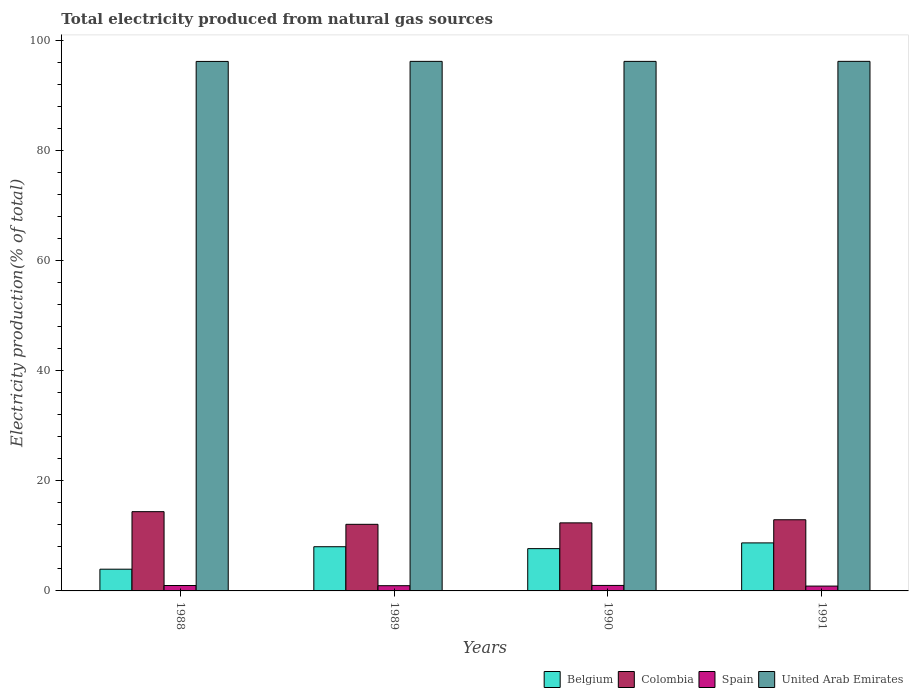How many different coloured bars are there?
Offer a terse response. 4. Are the number of bars per tick equal to the number of legend labels?
Your answer should be compact. Yes. In how many cases, is the number of bars for a given year not equal to the number of legend labels?
Ensure brevity in your answer.  0. What is the total electricity produced in Colombia in 1989?
Your answer should be compact. 12.11. Across all years, what is the maximum total electricity produced in Spain?
Ensure brevity in your answer.  1. Across all years, what is the minimum total electricity produced in Belgium?
Keep it short and to the point. 3.95. In which year was the total electricity produced in Belgium minimum?
Your response must be concise. 1988. What is the total total electricity produced in Spain in the graph?
Offer a terse response. 3.81. What is the difference between the total electricity produced in Belgium in 1989 and that in 1991?
Offer a very short reply. -0.7. What is the difference between the total electricity produced in United Arab Emirates in 1989 and the total electricity produced in Spain in 1991?
Offer a terse response. 95.41. What is the average total electricity produced in Belgium per year?
Offer a terse response. 7.1. In the year 1991, what is the difference between the total electricity produced in Spain and total electricity produced in United Arab Emirates?
Your response must be concise. -95.41. In how many years, is the total electricity produced in Spain greater than 16 %?
Offer a terse response. 0. What is the ratio of the total electricity produced in Colombia in 1990 to that in 1991?
Offer a very short reply. 0.96. Is the total electricity produced in United Arab Emirates in 1988 less than that in 1989?
Your answer should be compact. Yes. What is the difference between the highest and the second highest total electricity produced in Colombia?
Make the answer very short. 1.47. What is the difference between the highest and the lowest total electricity produced in Colombia?
Give a very brief answer. 2.3. Is the sum of the total electricity produced in Spain in 1988 and 1991 greater than the maximum total electricity produced in Colombia across all years?
Provide a short and direct response. No. Is it the case that in every year, the sum of the total electricity produced in Colombia and total electricity produced in United Arab Emirates is greater than the sum of total electricity produced in Belgium and total electricity produced in Spain?
Offer a very short reply. No. What does the 2nd bar from the left in 1988 represents?
Make the answer very short. Colombia. What does the 2nd bar from the right in 1988 represents?
Your response must be concise. Spain. Are all the bars in the graph horizontal?
Offer a terse response. No. How many years are there in the graph?
Offer a terse response. 4. What is the difference between two consecutive major ticks on the Y-axis?
Provide a short and direct response. 20. How many legend labels are there?
Give a very brief answer. 4. What is the title of the graph?
Ensure brevity in your answer.  Total electricity produced from natural gas sources. What is the Electricity production(% of total) in Belgium in 1988?
Give a very brief answer. 3.95. What is the Electricity production(% of total) of Colombia in 1988?
Your answer should be compact. 14.41. What is the Electricity production(% of total) in Spain in 1988?
Offer a very short reply. 0.98. What is the Electricity production(% of total) in United Arab Emirates in 1988?
Make the answer very short. 96.28. What is the Electricity production(% of total) of Belgium in 1989?
Make the answer very short. 8.04. What is the Electricity production(% of total) in Colombia in 1989?
Offer a terse response. 12.11. What is the Electricity production(% of total) of Spain in 1989?
Make the answer very short. 0.95. What is the Electricity production(% of total) in United Arab Emirates in 1989?
Offer a terse response. 96.29. What is the Electricity production(% of total) of Belgium in 1990?
Offer a terse response. 7.69. What is the Electricity production(% of total) in Colombia in 1990?
Provide a succinct answer. 12.37. What is the Electricity production(% of total) in Spain in 1990?
Provide a short and direct response. 1. What is the Electricity production(% of total) in United Arab Emirates in 1990?
Your response must be concise. 96.29. What is the Electricity production(% of total) of Belgium in 1991?
Your answer should be very brief. 8.73. What is the Electricity production(% of total) in Colombia in 1991?
Your answer should be very brief. 12.94. What is the Electricity production(% of total) in Spain in 1991?
Your answer should be very brief. 0.88. What is the Electricity production(% of total) in United Arab Emirates in 1991?
Ensure brevity in your answer.  96.29. Across all years, what is the maximum Electricity production(% of total) in Belgium?
Ensure brevity in your answer.  8.73. Across all years, what is the maximum Electricity production(% of total) in Colombia?
Provide a succinct answer. 14.41. Across all years, what is the maximum Electricity production(% of total) of Spain?
Provide a short and direct response. 1. Across all years, what is the maximum Electricity production(% of total) in United Arab Emirates?
Keep it short and to the point. 96.29. Across all years, what is the minimum Electricity production(% of total) of Belgium?
Keep it short and to the point. 3.95. Across all years, what is the minimum Electricity production(% of total) in Colombia?
Offer a terse response. 12.11. Across all years, what is the minimum Electricity production(% of total) in Spain?
Ensure brevity in your answer.  0.88. Across all years, what is the minimum Electricity production(% of total) of United Arab Emirates?
Offer a very short reply. 96.28. What is the total Electricity production(% of total) of Belgium in the graph?
Make the answer very short. 28.41. What is the total Electricity production(% of total) in Colombia in the graph?
Provide a succinct answer. 51.84. What is the total Electricity production(% of total) in Spain in the graph?
Give a very brief answer. 3.81. What is the total Electricity production(% of total) in United Arab Emirates in the graph?
Give a very brief answer. 385.15. What is the difference between the Electricity production(% of total) in Belgium in 1988 and that in 1989?
Offer a terse response. -4.09. What is the difference between the Electricity production(% of total) of Colombia in 1988 and that in 1989?
Provide a short and direct response. 2.3. What is the difference between the Electricity production(% of total) of Spain in 1988 and that in 1989?
Offer a terse response. 0.04. What is the difference between the Electricity production(% of total) of United Arab Emirates in 1988 and that in 1989?
Provide a succinct answer. -0.01. What is the difference between the Electricity production(% of total) in Belgium in 1988 and that in 1990?
Give a very brief answer. -3.74. What is the difference between the Electricity production(% of total) in Colombia in 1988 and that in 1990?
Give a very brief answer. 2.04. What is the difference between the Electricity production(% of total) in Spain in 1988 and that in 1990?
Your response must be concise. -0.01. What is the difference between the Electricity production(% of total) of United Arab Emirates in 1988 and that in 1990?
Your response must be concise. -0.01. What is the difference between the Electricity production(% of total) of Belgium in 1988 and that in 1991?
Your response must be concise. -4.78. What is the difference between the Electricity production(% of total) of Colombia in 1988 and that in 1991?
Provide a succinct answer. 1.47. What is the difference between the Electricity production(% of total) of Spain in 1988 and that in 1991?
Keep it short and to the point. 0.11. What is the difference between the Electricity production(% of total) in United Arab Emirates in 1988 and that in 1991?
Offer a terse response. -0.01. What is the difference between the Electricity production(% of total) in Belgium in 1989 and that in 1990?
Offer a very short reply. 0.35. What is the difference between the Electricity production(% of total) of Colombia in 1989 and that in 1990?
Offer a terse response. -0.26. What is the difference between the Electricity production(% of total) in Spain in 1989 and that in 1990?
Offer a very short reply. -0.05. What is the difference between the Electricity production(% of total) in United Arab Emirates in 1989 and that in 1990?
Offer a very short reply. 0. What is the difference between the Electricity production(% of total) in Belgium in 1989 and that in 1991?
Offer a terse response. -0.7. What is the difference between the Electricity production(% of total) of Colombia in 1989 and that in 1991?
Your answer should be very brief. -0.83. What is the difference between the Electricity production(% of total) in Spain in 1989 and that in 1991?
Keep it short and to the point. 0.07. What is the difference between the Electricity production(% of total) in United Arab Emirates in 1989 and that in 1991?
Keep it short and to the point. -0. What is the difference between the Electricity production(% of total) in Belgium in 1990 and that in 1991?
Ensure brevity in your answer.  -1.04. What is the difference between the Electricity production(% of total) in Colombia in 1990 and that in 1991?
Your response must be concise. -0.56. What is the difference between the Electricity production(% of total) in Spain in 1990 and that in 1991?
Provide a short and direct response. 0.12. What is the difference between the Electricity production(% of total) of United Arab Emirates in 1990 and that in 1991?
Your response must be concise. -0.01. What is the difference between the Electricity production(% of total) of Belgium in 1988 and the Electricity production(% of total) of Colombia in 1989?
Offer a very short reply. -8.16. What is the difference between the Electricity production(% of total) of Belgium in 1988 and the Electricity production(% of total) of Spain in 1989?
Give a very brief answer. 3. What is the difference between the Electricity production(% of total) in Belgium in 1988 and the Electricity production(% of total) in United Arab Emirates in 1989?
Provide a short and direct response. -92.34. What is the difference between the Electricity production(% of total) of Colombia in 1988 and the Electricity production(% of total) of Spain in 1989?
Keep it short and to the point. 13.46. What is the difference between the Electricity production(% of total) in Colombia in 1988 and the Electricity production(% of total) in United Arab Emirates in 1989?
Your response must be concise. -81.88. What is the difference between the Electricity production(% of total) of Spain in 1988 and the Electricity production(% of total) of United Arab Emirates in 1989?
Provide a succinct answer. -95.31. What is the difference between the Electricity production(% of total) of Belgium in 1988 and the Electricity production(% of total) of Colombia in 1990?
Keep it short and to the point. -8.43. What is the difference between the Electricity production(% of total) of Belgium in 1988 and the Electricity production(% of total) of Spain in 1990?
Offer a terse response. 2.95. What is the difference between the Electricity production(% of total) in Belgium in 1988 and the Electricity production(% of total) in United Arab Emirates in 1990?
Provide a short and direct response. -92.34. What is the difference between the Electricity production(% of total) of Colombia in 1988 and the Electricity production(% of total) of Spain in 1990?
Provide a short and direct response. 13.41. What is the difference between the Electricity production(% of total) of Colombia in 1988 and the Electricity production(% of total) of United Arab Emirates in 1990?
Make the answer very short. -81.88. What is the difference between the Electricity production(% of total) in Spain in 1988 and the Electricity production(% of total) in United Arab Emirates in 1990?
Keep it short and to the point. -95.3. What is the difference between the Electricity production(% of total) of Belgium in 1988 and the Electricity production(% of total) of Colombia in 1991?
Provide a short and direct response. -8.99. What is the difference between the Electricity production(% of total) in Belgium in 1988 and the Electricity production(% of total) in Spain in 1991?
Ensure brevity in your answer.  3.07. What is the difference between the Electricity production(% of total) of Belgium in 1988 and the Electricity production(% of total) of United Arab Emirates in 1991?
Your response must be concise. -92.34. What is the difference between the Electricity production(% of total) of Colombia in 1988 and the Electricity production(% of total) of Spain in 1991?
Offer a terse response. 13.53. What is the difference between the Electricity production(% of total) of Colombia in 1988 and the Electricity production(% of total) of United Arab Emirates in 1991?
Make the answer very short. -81.88. What is the difference between the Electricity production(% of total) in Spain in 1988 and the Electricity production(% of total) in United Arab Emirates in 1991?
Offer a very short reply. -95.31. What is the difference between the Electricity production(% of total) in Belgium in 1989 and the Electricity production(% of total) in Colombia in 1990?
Ensure brevity in your answer.  -4.34. What is the difference between the Electricity production(% of total) in Belgium in 1989 and the Electricity production(% of total) in Spain in 1990?
Your response must be concise. 7.04. What is the difference between the Electricity production(% of total) of Belgium in 1989 and the Electricity production(% of total) of United Arab Emirates in 1990?
Ensure brevity in your answer.  -88.25. What is the difference between the Electricity production(% of total) of Colombia in 1989 and the Electricity production(% of total) of Spain in 1990?
Make the answer very short. 11.11. What is the difference between the Electricity production(% of total) in Colombia in 1989 and the Electricity production(% of total) in United Arab Emirates in 1990?
Offer a terse response. -84.18. What is the difference between the Electricity production(% of total) in Spain in 1989 and the Electricity production(% of total) in United Arab Emirates in 1990?
Offer a very short reply. -95.34. What is the difference between the Electricity production(% of total) in Belgium in 1989 and the Electricity production(% of total) in Colombia in 1991?
Your response must be concise. -4.9. What is the difference between the Electricity production(% of total) in Belgium in 1989 and the Electricity production(% of total) in Spain in 1991?
Ensure brevity in your answer.  7.16. What is the difference between the Electricity production(% of total) of Belgium in 1989 and the Electricity production(% of total) of United Arab Emirates in 1991?
Provide a succinct answer. -88.26. What is the difference between the Electricity production(% of total) of Colombia in 1989 and the Electricity production(% of total) of Spain in 1991?
Provide a short and direct response. 11.23. What is the difference between the Electricity production(% of total) of Colombia in 1989 and the Electricity production(% of total) of United Arab Emirates in 1991?
Offer a very short reply. -84.18. What is the difference between the Electricity production(% of total) of Spain in 1989 and the Electricity production(% of total) of United Arab Emirates in 1991?
Your answer should be compact. -95.34. What is the difference between the Electricity production(% of total) of Belgium in 1990 and the Electricity production(% of total) of Colombia in 1991?
Your response must be concise. -5.25. What is the difference between the Electricity production(% of total) of Belgium in 1990 and the Electricity production(% of total) of Spain in 1991?
Your answer should be compact. 6.81. What is the difference between the Electricity production(% of total) of Belgium in 1990 and the Electricity production(% of total) of United Arab Emirates in 1991?
Offer a very short reply. -88.6. What is the difference between the Electricity production(% of total) in Colombia in 1990 and the Electricity production(% of total) in Spain in 1991?
Give a very brief answer. 11.49. What is the difference between the Electricity production(% of total) in Colombia in 1990 and the Electricity production(% of total) in United Arab Emirates in 1991?
Offer a very short reply. -83.92. What is the difference between the Electricity production(% of total) in Spain in 1990 and the Electricity production(% of total) in United Arab Emirates in 1991?
Offer a very short reply. -95.3. What is the average Electricity production(% of total) in Belgium per year?
Keep it short and to the point. 7.1. What is the average Electricity production(% of total) of Colombia per year?
Make the answer very short. 12.96. What is the average Electricity production(% of total) of Spain per year?
Make the answer very short. 0.95. What is the average Electricity production(% of total) of United Arab Emirates per year?
Offer a very short reply. 96.29. In the year 1988, what is the difference between the Electricity production(% of total) in Belgium and Electricity production(% of total) in Colombia?
Your answer should be compact. -10.46. In the year 1988, what is the difference between the Electricity production(% of total) in Belgium and Electricity production(% of total) in Spain?
Your answer should be compact. 2.96. In the year 1988, what is the difference between the Electricity production(% of total) in Belgium and Electricity production(% of total) in United Arab Emirates?
Provide a succinct answer. -92.33. In the year 1988, what is the difference between the Electricity production(% of total) in Colombia and Electricity production(% of total) in Spain?
Your response must be concise. 13.43. In the year 1988, what is the difference between the Electricity production(% of total) of Colombia and Electricity production(% of total) of United Arab Emirates?
Make the answer very short. -81.87. In the year 1988, what is the difference between the Electricity production(% of total) of Spain and Electricity production(% of total) of United Arab Emirates?
Make the answer very short. -95.3. In the year 1989, what is the difference between the Electricity production(% of total) of Belgium and Electricity production(% of total) of Colombia?
Your response must be concise. -4.07. In the year 1989, what is the difference between the Electricity production(% of total) in Belgium and Electricity production(% of total) in Spain?
Offer a very short reply. 7.09. In the year 1989, what is the difference between the Electricity production(% of total) of Belgium and Electricity production(% of total) of United Arab Emirates?
Provide a succinct answer. -88.26. In the year 1989, what is the difference between the Electricity production(% of total) in Colombia and Electricity production(% of total) in Spain?
Keep it short and to the point. 11.16. In the year 1989, what is the difference between the Electricity production(% of total) in Colombia and Electricity production(% of total) in United Arab Emirates?
Your response must be concise. -84.18. In the year 1989, what is the difference between the Electricity production(% of total) in Spain and Electricity production(% of total) in United Arab Emirates?
Make the answer very short. -95.34. In the year 1990, what is the difference between the Electricity production(% of total) of Belgium and Electricity production(% of total) of Colombia?
Keep it short and to the point. -4.69. In the year 1990, what is the difference between the Electricity production(% of total) of Belgium and Electricity production(% of total) of Spain?
Make the answer very short. 6.69. In the year 1990, what is the difference between the Electricity production(% of total) of Belgium and Electricity production(% of total) of United Arab Emirates?
Keep it short and to the point. -88.6. In the year 1990, what is the difference between the Electricity production(% of total) in Colombia and Electricity production(% of total) in Spain?
Offer a terse response. 11.38. In the year 1990, what is the difference between the Electricity production(% of total) in Colombia and Electricity production(% of total) in United Arab Emirates?
Keep it short and to the point. -83.91. In the year 1990, what is the difference between the Electricity production(% of total) in Spain and Electricity production(% of total) in United Arab Emirates?
Offer a very short reply. -95.29. In the year 1991, what is the difference between the Electricity production(% of total) in Belgium and Electricity production(% of total) in Colombia?
Offer a very short reply. -4.21. In the year 1991, what is the difference between the Electricity production(% of total) in Belgium and Electricity production(% of total) in Spain?
Offer a very short reply. 7.85. In the year 1991, what is the difference between the Electricity production(% of total) of Belgium and Electricity production(% of total) of United Arab Emirates?
Offer a terse response. -87.56. In the year 1991, what is the difference between the Electricity production(% of total) of Colombia and Electricity production(% of total) of Spain?
Ensure brevity in your answer.  12.06. In the year 1991, what is the difference between the Electricity production(% of total) of Colombia and Electricity production(% of total) of United Arab Emirates?
Your answer should be very brief. -83.36. In the year 1991, what is the difference between the Electricity production(% of total) in Spain and Electricity production(% of total) in United Arab Emirates?
Make the answer very short. -95.41. What is the ratio of the Electricity production(% of total) in Belgium in 1988 to that in 1989?
Ensure brevity in your answer.  0.49. What is the ratio of the Electricity production(% of total) in Colombia in 1988 to that in 1989?
Keep it short and to the point. 1.19. What is the ratio of the Electricity production(% of total) in Spain in 1988 to that in 1989?
Provide a succinct answer. 1.04. What is the ratio of the Electricity production(% of total) in Belgium in 1988 to that in 1990?
Keep it short and to the point. 0.51. What is the ratio of the Electricity production(% of total) in Colombia in 1988 to that in 1990?
Offer a very short reply. 1.16. What is the ratio of the Electricity production(% of total) in Spain in 1988 to that in 1990?
Your response must be concise. 0.99. What is the ratio of the Electricity production(% of total) of Belgium in 1988 to that in 1991?
Provide a succinct answer. 0.45. What is the ratio of the Electricity production(% of total) in Colombia in 1988 to that in 1991?
Ensure brevity in your answer.  1.11. What is the ratio of the Electricity production(% of total) in Spain in 1988 to that in 1991?
Your answer should be very brief. 1.12. What is the ratio of the Electricity production(% of total) of United Arab Emirates in 1988 to that in 1991?
Make the answer very short. 1. What is the ratio of the Electricity production(% of total) in Belgium in 1989 to that in 1990?
Offer a terse response. 1.04. What is the ratio of the Electricity production(% of total) in Colombia in 1989 to that in 1990?
Make the answer very short. 0.98. What is the ratio of the Electricity production(% of total) in Spain in 1989 to that in 1990?
Ensure brevity in your answer.  0.95. What is the ratio of the Electricity production(% of total) in United Arab Emirates in 1989 to that in 1990?
Your response must be concise. 1. What is the ratio of the Electricity production(% of total) of Belgium in 1989 to that in 1991?
Your response must be concise. 0.92. What is the ratio of the Electricity production(% of total) of Colombia in 1989 to that in 1991?
Make the answer very short. 0.94. What is the ratio of the Electricity production(% of total) of Spain in 1989 to that in 1991?
Keep it short and to the point. 1.08. What is the ratio of the Electricity production(% of total) in United Arab Emirates in 1989 to that in 1991?
Provide a short and direct response. 1. What is the ratio of the Electricity production(% of total) in Belgium in 1990 to that in 1991?
Your answer should be very brief. 0.88. What is the ratio of the Electricity production(% of total) in Colombia in 1990 to that in 1991?
Ensure brevity in your answer.  0.96. What is the ratio of the Electricity production(% of total) of Spain in 1990 to that in 1991?
Offer a terse response. 1.13. What is the difference between the highest and the second highest Electricity production(% of total) in Belgium?
Give a very brief answer. 0.7. What is the difference between the highest and the second highest Electricity production(% of total) of Colombia?
Give a very brief answer. 1.47. What is the difference between the highest and the second highest Electricity production(% of total) of Spain?
Ensure brevity in your answer.  0.01. What is the difference between the highest and the second highest Electricity production(% of total) in United Arab Emirates?
Give a very brief answer. 0. What is the difference between the highest and the lowest Electricity production(% of total) of Belgium?
Give a very brief answer. 4.78. What is the difference between the highest and the lowest Electricity production(% of total) in Colombia?
Your response must be concise. 2.3. What is the difference between the highest and the lowest Electricity production(% of total) in Spain?
Give a very brief answer. 0.12. What is the difference between the highest and the lowest Electricity production(% of total) in United Arab Emirates?
Your response must be concise. 0.01. 